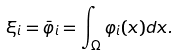Convert formula to latex. <formula><loc_0><loc_0><loc_500><loc_500>\xi _ { i } = \bar { \varphi } _ { i } = \int _ { \Omega } \varphi _ { i } ( x ) d x .</formula> 